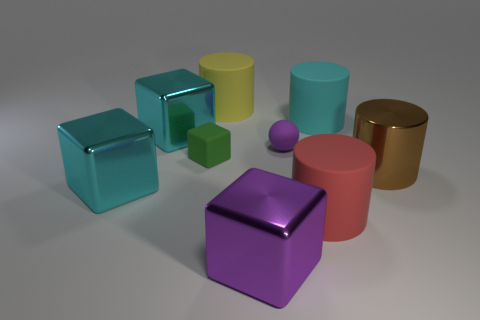Subtract all big cubes. How many cubes are left? 1 Subtract all purple balls. How many cyan cubes are left? 2 Subtract all brown cylinders. How many cylinders are left? 3 Subtract all cubes. How many objects are left? 5 Add 1 small green spheres. How many objects exist? 10 Subtract 2 cylinders. How many cylinders are left? 2 Add 8 big cyan metal objects. How many big cyan metal objects are left? 10 Add 6 tiny blue rubber things. How many tiny blue rubber things exist? 6 Subtract 0 green cylinders. How many objects are left? 9 Subtract all gray spheres. Subtract all yellow cylinders. How many spheres are left? 1 